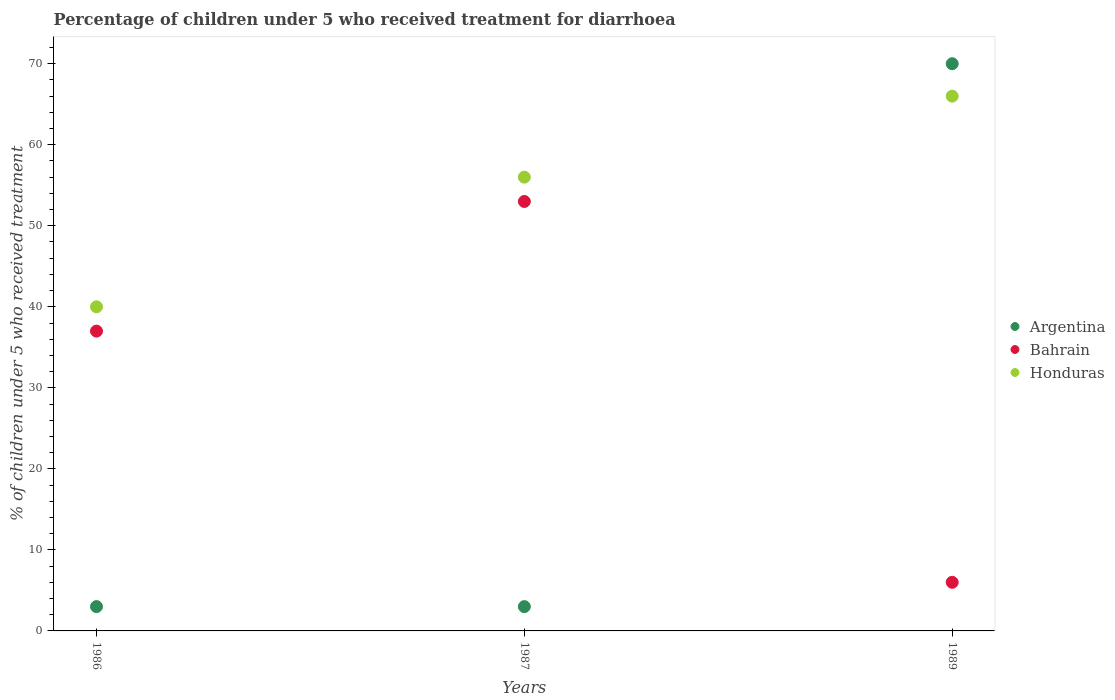Across all years, what is the maximum percentage of children who received treatment for diarrhoea  in Honduras?
Give a very brief answer. 66. Across all years, what is the minimum percentage of children who received treatment for diarrhoea  in Bahrain?
Give a very brief answer. 6. In which year was the percentage of children who received treatment for diarrhoea  in Honduras minimum?
Make the answer very short. 1986. What is the total percentage of children who received treatment for diarrhoea  in Honduras in the graph?
Your answer should be compact. 162. What is the difference between the percentage of children who received treatment for diarrhoea  in Argentina in 1987 and that in 1989?
Offer a very short reply. -67. In the year 1986, what is the difference between the percentage of children who received treatment for diarrhoea  in Honduras and percentage of children who received treatment for diarrhoea  in Bahrain?
Your response must be concise. 3. What is the ratio of the percentage of children who received treatment for diarrhoea  in Bahrain in 1986 to that in 1989?
Give a very brief answer. 6.17. Is the difference between the percentage of children who received treatment for diarrhoea  in Honduras in 1986 and 1987 greater than the difference between the percentage of children who received treatment for diarrhoea  in Bahrain in 1986 and 1987?
Your response must be concise. No. What is the difference between the highest and the second highest percentage of children who received treatment for diarrhoea  in Honduras?
Offer a very short reply. 10. In how many years, is the percentage of children who received treatment for diarrhoea  in Bahrain greater than the average percentage of children who received treatment for diarrhoea  in Bahrain taken over all years?
Provide a succinct answer. 2. Is the sum of the percentage of children who received treatment for diarrhoea  in Argentina in 1986 and 1989 greater than the maximum percentage of children who received treatment for diarrhoea  in Honduras across all years?
Ensure brevity in your answer.  Yes. Is it the case that in every year, the sum of the percentage of children who received treatment for diarrhoea  in Argentina and percentage of children who received treatment for diarrhoea  in Bahrain  is greater than the percentage of children who received treatment for diarrhoea  in Honduras?
Ensure brevity in your answer.  No. Does the percentage of children who received treatment for diarrhoea  in Argentina monotonically increase over the years?
Keep it short and to the point. No. How many dotlines are there?
Ensure brevity in your answer.  3. How many years are there in the graph?
Offer a very short reply. 3. What is the difference between two consecutive major ticks on the Y-axis?
Provide a short and direct response. 10. Does the graph contain grids?
Offer a very short reply. No. Where does the legend appear in the graph?
Make the answer very short. Center right. How many legend labels are there?
Provide a short and direct response. 3. How are the legend labels stacked?
Offer a very short reply. Vertical. What is the title of the graph?
Ensure brevity in your answer.  Percentage of children under 5 who received treatment for diarrhoea. Does "Tunisia" appear as one of the legend labels in the graph?
Ensure brevity in your answer.  No. What is the label or title of the Y-axis?
Provide a short and direct response. % of children under 5 who received treatment. What is the % of children under 5 who received treatment in Argentina in 1986?
Your answer should be compact. 3. What is the % of children under 5 who received treatment of Argentina in 1987?
Provide a short and direct response. 3. What is the % of children under 5 who received treatment in Bahrain in 1987?
Your response must be concise. 53. What is the % of children under 5 who received treatment of Bahrain in 1989?
Ensure brevity in your answer.  6. What is the % of children under 5 who received treatment in Honduras in 1989?
Offer a very short reply. 66. Across all years, what is the maximum % of children under 5 who received treatment in Honduras?
Your response must be concise. 66. Across all years, what is the minimum % of children under 5 who received treatment of Bahrain?
Your answer should be very brief. 6. What is the total % of children under 5 who received treatment of Argentina in the graph?
Your answer should be very brief. 76. What is the total % of children under 5 who received treatment of Bahrain in the graph?
Offer a terse response. 96. What is the total % of children under 5 who received treatment of Honduras in the graph?
Offer a very short reply. 162. What is the difference between the % of children under 5 who received treatment in Argentina in 1986 and that in 1987?
Provide a succinct answer. 0. What is the difference between the % of children under 5 who received treatment of Bahrain in 1986 and that in 1987?
Your answer should be very brief. -16. What is the difference between the % of children under 5 who received treatment of Honduras in 1986 and that in 1987?
Ensure brevity in your answer.  -16. What is the difference between the % of children under 5 who received treatment in Argentina in 1986 and that in 1989?
Offer a terse response. -67. What is the difference between the % of children under 5 who received treatment in Bahrain in 1986 and that in 1989?
Ensure brevity in your answer.  31. What is the difference between the % of children under 5 who received treatment of Argentina in 1987 and that in 1989?
Ensure brevity in your answer.  -67. What is the difference between the % of children under 5 who received treatment in Bahrain in 1987 and that in 1989?
Keep it short and to the point. 47. What is the difference between the % of children under 5 who received treatment of Argentina in 1986 and the % of children under 5 who received treatment of Honduras in 1987?
Give a very brief answer. -53. What is the difference between the % of children under 5 who received treatment in Bahrain in 1986 and the % of children under 5 who received treatment in Honduras in 1987?
Offer a very short reply. -19. What is the difference between the % of children under 5 who received treatment in Argentina in 1986 and the % of children under 5 who received treatment in Honduras in 1989?
Offer a very short reply. -63. What is the difference between the % of children under 5 who received treatment in Argentina in 1987 and the % of children under 5 who received treatment in Honduras in 1989?
Your answer should be very brief. -63. What is the average % of children under 5 who received treatment in Argentina per year?
Your answer should be very brief. 25.33. What is the average % of children under 5 who received treatment of Bahrain per year?
Your answer should be compact. 32. What is the average % of children under 5 who received treatment of Honduras per year?
Provide a short and direct response. 54. In the year 1986, what is the difference between the % of children under 5 who received treatment in Argentina and % of children under 5 who received treatment in Bahrain?
Provide a short and direct response. -34. In the year 1986, what is the difference between the % of children under 5 who received treatment in Argentina and % of children under 5 who received treatment in Honduras?
Your answer should be very brief. -37. In the year 1986, what is the difference between the % of children under 5 who received treatment of Bahrain and % of children under 5 who received treatment of Honduras?
Keep it short and to the point. -3. In the year 1987, what is the difference between the % of children under 5 who received treatment of Argentina and % of children under 5 who received treatment of Bahrain?
Offer a very short reply. -50. In the year 1987, what is the difference between the % of children under 5 who received treatment in Argentina and % of children under 5 who received treatment in Honduras?
Offer a very short reply. -53. In the year 1987, what is the difference between the % of children under 5 who received treatment of Bahrain and % of children under 5 who received treatment of Honduras?
Keep it short and to the point. -3. In the year 1989, what is the difference between the % of children under 5 who received treatment in Argentina and % of children under 5 who received treatment in Honduras?
Provide a short and direct response. 4. In the year 1989, what is the difference between the % of children under 5 who received treatment in Bahrain and % of children under 5 who received treatment in Honduras?
Offer a terse response. -60. What is the ratio of the % of children under 5 who received treatment of Bahrain in 1986 to that in 1987?
Ensure brevity in your answer.  0.7. What is the ratio of the % of children under 5 who received treatment of Argentina in 1986 to that in 1989?
Provide a short and direct response. 0.04. What is the ratio of the % of children under 5 who received treatment of Bahrain in 1986 to that in 1989?
Make the answer very short. 6.17. What is the ratio of the % of children under 5 who received treatment of Honduras in 1986 to that in 1989?
Your response must be concise. 0.61. What is the ratio of the % of children under 5 who received treatment in Argentina in 1987 to that in 1989?
Keep it short and to the point. 0.04. What is the ratio of the % of children under 5 who received treatment of Bahrain in 1987 to that in 1989?
Your answer should be compact. 8.83. What is the ratio of the % of children under 5 who received treatment in Honduras in 1987 to that in 1989?
Your answer should be compact. 0.85. What is the difference between the highest and the second highest % of children under 5 who received treatment of Honduras?
Your answer should be very brief. 10. 